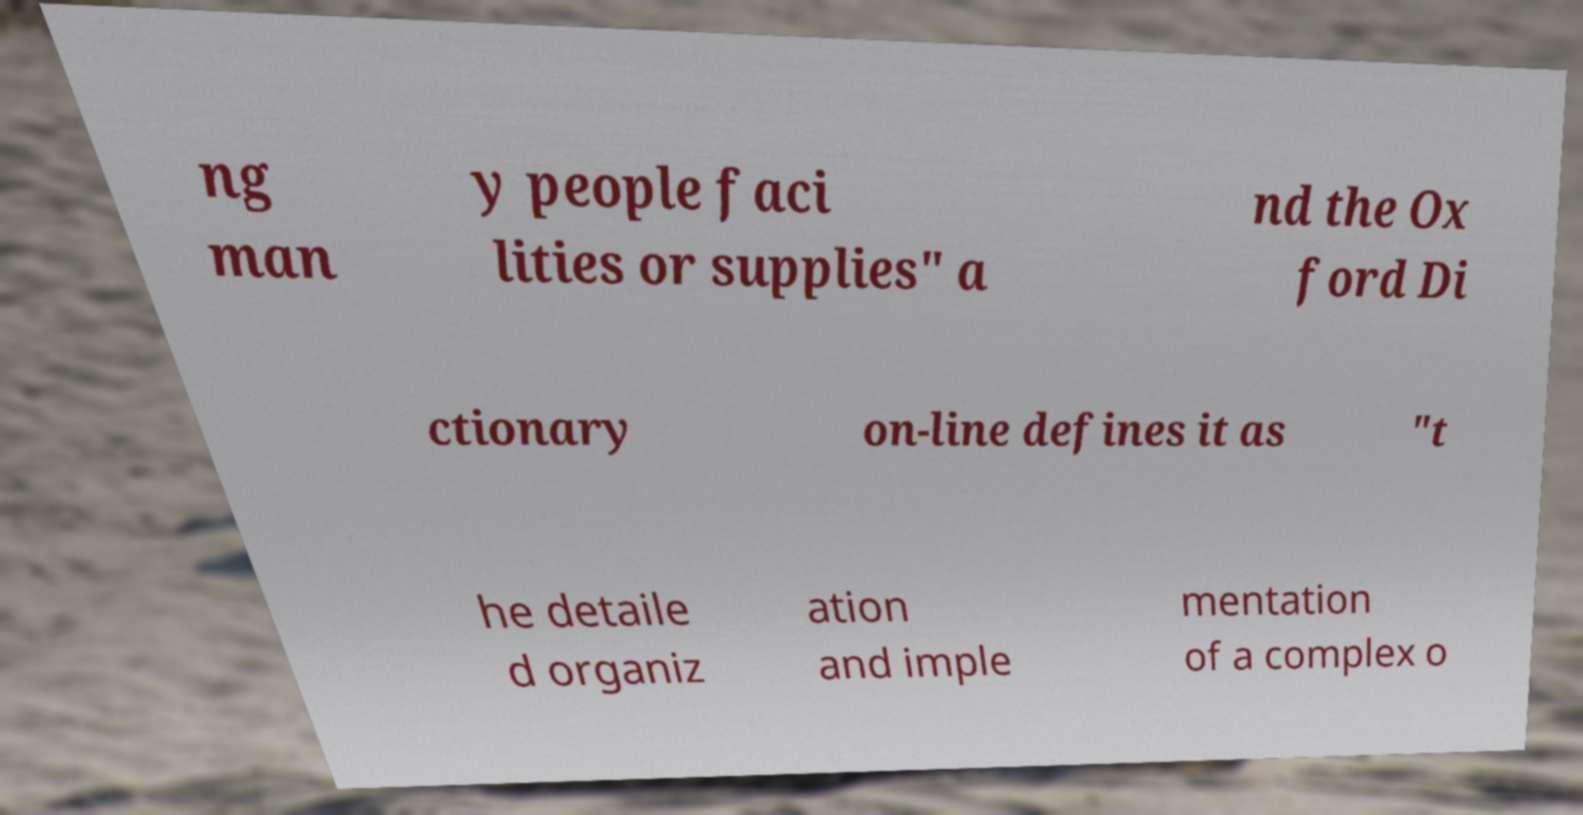What messages or text are displayed in this image? I need them in a readable, typed format. ng man y people faci lities or supplies" a nd the Ox ford Di ctionary on-line defines it as "t he detaile d organiz ation and imple mentation of a complex o 